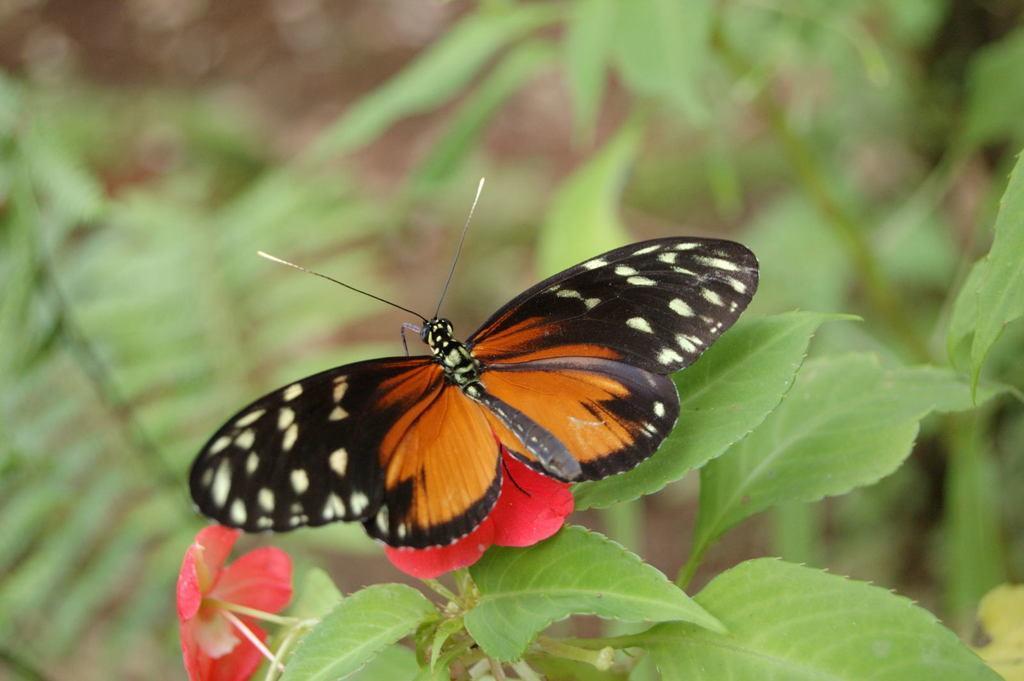Describe this image in one or two sentences. In this image there is a butterfly on a flower, in the background there are leaves and it is blurred. 